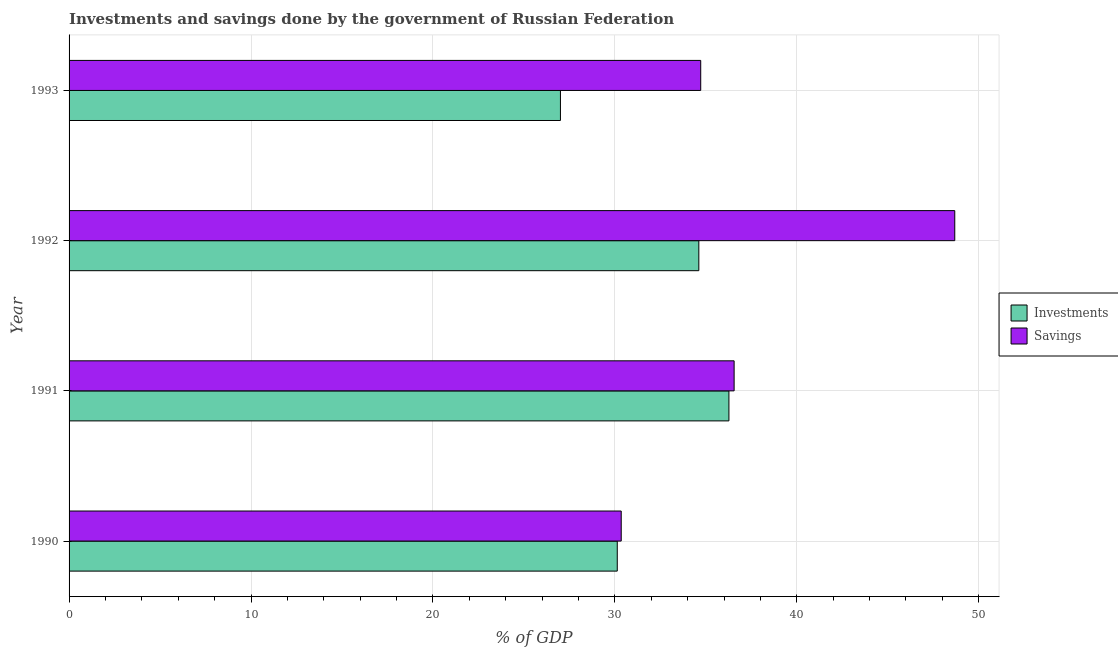Are the number of bars on each tick of the Y-axis equal?
Your answer should be very brief. Yes. How many bars are there on the 2nd tick from the top?
Make the answer very short. 2. In how many cases, is the number of bars for a given year not equal to the number of legend labels?
Offer a very short reply. 0. What is the savings of government in 1992?
Your answer should be compact. 48.68. Across all years, what is the maximum investments of government?
Give a very brief answer. 36.27. Across all years, what is the minimum investments of government?
Offer a terse response. 27.01. In which year was the savings of government maximum?
Give a very brief answer. 1992. In which year was the savings of government minimum?
Your response must be concise. 1990. What is the total investments of government in the graph?
Keep it short and to the point. 128.02. What is the difference between the investments of government in 1990 and that in 1991?
Provide a short and direct response. -6.14. What is the difference between the investments of government in 1991 and the savings of government in 1992?
Your response must be concise. -12.41. What is the average savings of government per year?
Your answer should be compact. 37.58. In the year 1991, what is the difference between the savings of government and investments of government?
Give a very brief answer. 0.29. What is the ratio of the investments of government in 1990 to that in 1991?
Your answer should be compact. 0.83. Is the difference between the savings of government in 1991 and 1993 greater than the difference between the investments of government in 1991 and 1993?
Make the answer very short. No. What is the difference between the highest and the second highest investments of government?
Ensure brevity in your answer.  1.65. What is the difference between the highest and the lowest savings of government?
Give a very brief answer. 18.33. In how many years, is the savings of government greater than the average savings of government taken over all years?
Provide a short and direct response. 1. What does the 2nd bar from the top in 1993 represents?
Make the answer very short. Investments. What does the 1st bar from the bottom in 1993 represents?
Make the answer very short. Investments. Are all the bars in the graph horizontal?
Make the answer very short. Yes. How many years are there in the graph?
Your answer should be very brief. 4. Are the values on the major ticks of X-axis written in scientific E-notation?
Ensure brevity in your answer.  No. Does the graph contain grids?
Your response must be concise. Yes. How many legend labels are there?
Make the answer very short. 2. How are the legend labels stacked?
Offer a terse response. Vertical. What is the title of the graph?
Provide a succinct answer. Investments and savings done by the government of Russian Federation. What is the label or title of the X-axis?
Make the answer very short. % of GDP. What is the % of GDP in Investments in 1990?
Provide a succinct answer. 30.13. What is the % of GDP in Savings in 1990?
Your response must be concise. 30.35. What is the % of GDP of Investments in 1991?
Your response must be concise. 36.27. What is the % of GDP of Savings in 1991?
Your answer should be very brief. 36.55. What is the % of GDP in Investments in 1992?
Your answer should be very brief. 34.61. What is the % of GDP of Savings in 1992?
Offer a very short reply. 48.68. What is the % of GDP in Investments in 1993?
Your response must be concise. 27.01. What is the % of GDP of Savings in 1993?
Offer a terse response. 34.72. Across all years, what is the maximum % of GDP in Investments?
Your answer should be compact. 36.27. Across all years, what is the maximum % of GDP of Savings?
Keep it short and to the point. 48.68. Across all years, what is the minimum % of GDP of Investments?
Provide a succinct answer. 27.01. Across all years, what is the minimum % of GDP of Savings?
Ensure brevity in your answer.  30.35. What is the total % of GDP in Investments in the graph?
Keep it short and to the point. 128.02. What is the total % of GDP of Savings in the graph?
Give a very brief answer. 150.3. What is the difference between the % of GDP in Investments in 1990 and that in 1991?
Offer a terse response. -6.14. What is the difference between the % of GDP of Savings in 1990 and that in 1991?
Keep it short and to the point. -6.21. What is the difference between the % of GDP of Investments in 1990 and that in 1992?
Your answer should be compact. -4.48. What is the difference between the % of GDP in Savings in 1990 and that in 1992?
Keep it short and to the point. -18.33. What is the difference between the % of GDP of Investments in 1990 and that in 1993?
Your answer should be very brief. 3.12. What is the difference between the % of GDP in Savings in 1990 and that in 1993?
Ensure brevity in your answer.  -4.37. What is the difference between the % of GDP of Investments in 1991 and that in 1992?
Provide a short and direct response. 1.65. What is the difference between the % of GDP of Savings in 1991 and that in 1992?
Offer a very short reply. -12.13. What is the difference between the % of GDP in Investments in 1991 and that in 1993?
Provide a short and direct response. 9.26. What is the difference between the % of GDP in Savings in 1991 and that in 1993?
Your answer should be very brief. 1.84. What is the difference between the % of GDP in Investments in 1992 and that in 1993?
Offer a very short reply. 7.61. What is the difference between the % of GDP in Savings in 1992 and that in 1993?
Offer a very short reply. 13.96. What is the difference between the % of GDP in Investments in 1990 and the % of GDP in Savings in 1991?
Make the answer very short. -6.42. What is the difference between the % of GDP in Investments in 1990 and the % of GDP in Savings in 1992?
Make the answer very short. -18.55. What is the difference between the % of GDP of Investments in 1990 and the % of GDP of Savings in 1993?
Keep it short and to the point. -4.59. What is the difference between the % of GDP in Investments in 1991 and the % of GDP in Savings in 1992?
Your answer should be compact. -12.41. What is the difference between the % of GDP of Investments in 1991 and the % of GDP of Savings in 1993?
Keep it short and to the point. 1.55. What is the difference between the % of GDP of Investments in 1992 and the % of GDP of Savings in 1993?
Give a very brief answer. -0.1. What is the average % of GDP of Investments per year?
Keep it short and to the point. 32. What is the average % of GDP in Savings per year?
Your answer should be compact. 37.58. In the year 1990, what is the difference between the % of GDP of Investments and % of GDP of Savings?
Your response must be concise. -0.22. In the year 1991, what is the difference between the % of GDP of Investments and % of GDP of Savings?
Your answer should be very brief. -0.29. In the year 1992, what is the difference between the % of GDP in Investments and % of GDP in Savings?
Keep it short and to the point. -14.07. In the year 1993, what is the difference between the % of GDP in Investments and % of GDP in Savings?
Your answer should be compact. -7.71. What is the ratio of the % of GDP in Investments in 1990 to that in 1991?
Your response must be concise. 0.83. What is the ratio of the % of GDP of Savings in 1990 to that in 1991?
Your answer should be very brief. 0.83. What is the ratio of the % of GDP in Investments in 1990 to that in 1992?
Ensure brevity in your answer.  0.87. What is the ratio of the % of GDP in Savings in 1990 to that in 1992?
Provide a short and direct response. 0.62. What is the ratio of the % of GDP in Investments in 1990 to that in 1993?
Your response must be concise. 1.12. What is the ratio of the % of GDP of Savings in 1990 to that in 1993?
Your answer should be compact. 0.87. What is the ratio of the % of GDP in Investments in 1991 to that in 1992?
Make the answer very short. 1.05. What is the ratio of the % of GDP of Savings in 1991 to that in 1992?
Provide a short and direct response. 0.75. What is the ratio of the % of GDP of Investments in 1991 to that in 1993?
Provide a succinct answer. 1.34. What is the ratio of the % of GDP of Savings in 1991 to that in 1993?
Give a very brief answer. 1.05. What is the ratio of the % of GDP of Investments in 1992 to that in 1993?
Your response must be concise. 1.28. What is the ratio of the % of GDP of Savings in 1992 to that in 1993?
Provide a short and direct response. 1.4. What is the difference between the highest and the second highest % of GDP of Investments?
Your response must be concise. 1.65. What is the difference between the highest and the second highest % of GDP in Savings?
Keep it short and to the point. 12.13. What is the difference between the highest and the lowest % of GDP of Investments?
Keep it short and to the point. 9.26. What is the difference between the highest and the lowest % of GDP in Savings?
Make the answer very short. 18.33. 